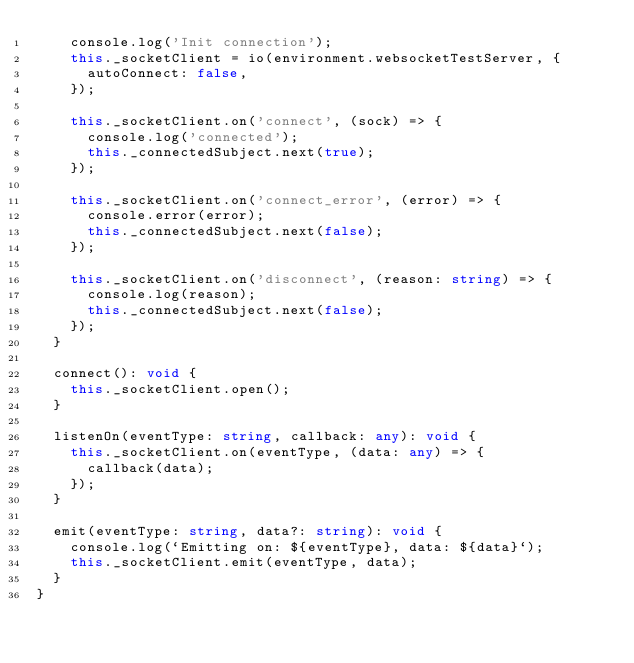<code> <loc_0><loc_0><loc_500><loc_500><_TypeScript_>    console.log('Init connection');
    this._socketClient = io(environment.websocketTestServer, {
      autoConnect: false,
    });

    this._socketClient.on('connect', (sock) => {
      console.log('connected');
      this._connectedSubject.next(true);
    });

    this._socketClient.on('connect_error', (error) => {
      console.error(error);
      this._connectedSubject.next(false);
    });

    this._socketClient.on('disconnect', (reason: string) => {
      console.log(reason);
      this._connectedSubject.next(false);
    });
  }

  connect(): void {
    this._socketClient.open();
  }

  listenOn(eventType: string, callback: any): void {
    this._socketClient.on(eventType, (data: any) => {
      callback(data);
    });
  }

  emit(eventType: string, data?: string): void {
    console.log(`Emitting on: ${eventType}, data: ${data}`);
    this._socketClient.emit(eventType, data);
  }
}
</code> 